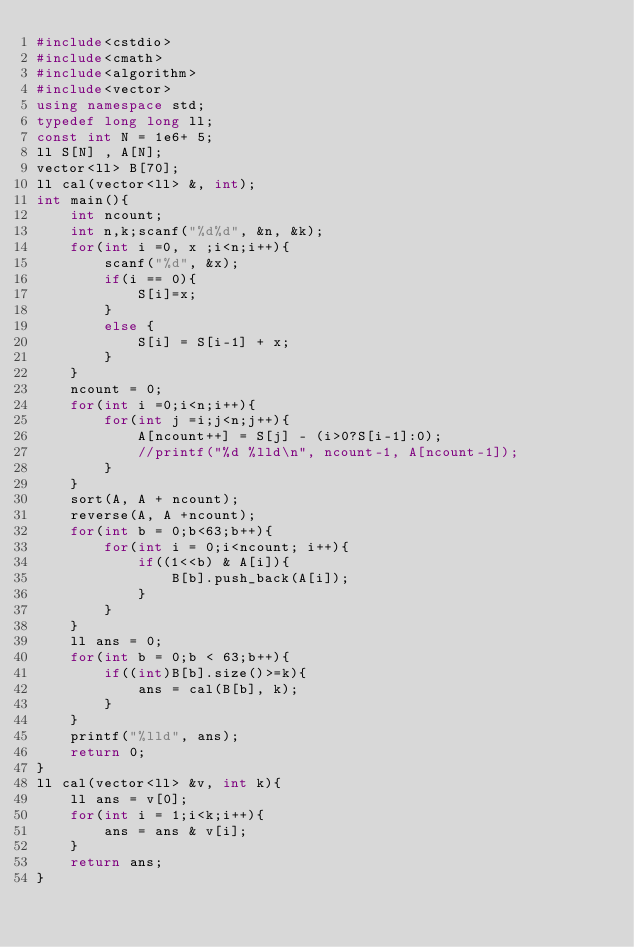<code> <loc_0><loc_0><loc_500><loc_500><_C++_>#include<cstdio>
#include<cmath>
#include<algorithm>
#include<vector>
using namespace std;
typedef long long ll;
const int N = 1e6+ 5;
ll S[N] , A[N];
vector<ll> B[70];
ll cal(vector<ll> &, int);
int main(){
    int ncount;
    int n,k;scanf("%d%d", &n, &k);
    for(int i =0, x ;i<n;i++){
        scanf("%d", &x);
        if(i == 0){
            S[i]=x;
        }
        else {
            S[i] = S[i-1] + x;
        }
    }
    ncount = 0;
    for(int i =0;i<n;i++){
        for(int j =i;j<n;j++){
            A[ncount++] = S[j] - (i>0?S[i-1]:0);
            //printf("%d %lld\n", ncount-1, A[ncount-1]);
        }
    }
    sort(A, A + ncount);
    reverse(A, A +ncount);
    for(int b = 0;b<63;b++){
        for(int i = 0;i<ncount; i++){
            if((1<<b) & A[i]){
                B[b].push_back(A[i]);
            }
        }
    }
    ll ans = 0;
    for(int b = 0;b < 63;b++){
        if((int)B[b].size()>=k){
            ans = cal(B[b], k);
        }
    }
    printf("%lld", ans);
    return 0;
}
ll cal(vector<ll> &v, int k){
    ll ans = v[0];
    for(int i = 1;i<k;i++){
        ans = ans & v[i];
    }
    return ans;
}
</code> 